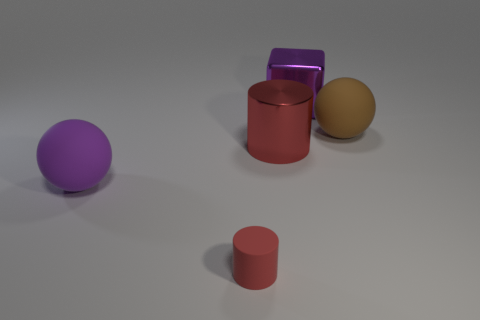Add 3 big purple metal cylinders. How many objects exist? 8 Subtract all cylinders. How many objects are left? 3 Subtract 2 red cylinders. How many objects are left? 3 Subtract all big purple things. Subtract all big purple spheres. How many objects are left? 2 Add 3 metal cylinders. How many metal cylinders are left? 4 Add 5 metallic cylinders. How many metallic cylinders exist? 6 